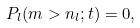<formula> <loc_0><loc_0><loc_500><loc_500>P _ { l } ( m > n _ { l } ; t ) = 0 ,</formula> 